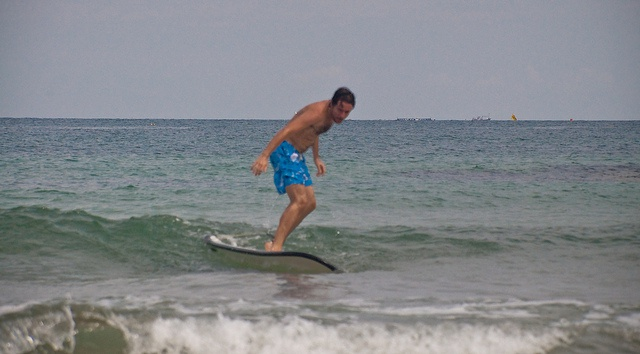Describe the objects in this image and their specific colors. I can see people in gray, brown, and blue tones and surfboard in gray, black, darkgreen, and darkgray tones in this image. 